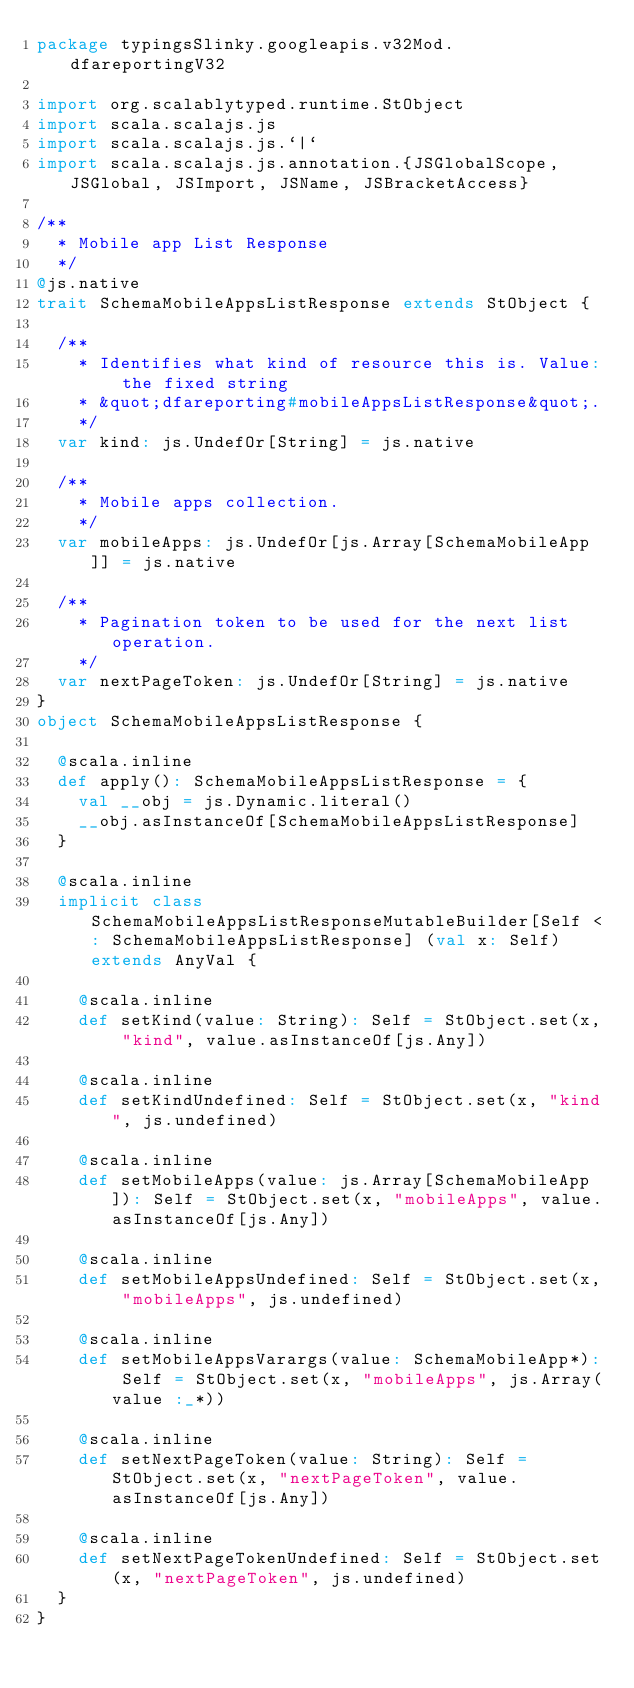Convert code to text. <code><loc_0><loc_0><loc_500><loc_500><_Scala_>package typingsSlinky.googleapis.v32Mod.dfareportingV32

import org.scalablytyped.runtime.StObject
import scala.scalajs.js
import scala.scalajs.js.`|`
import scala.scalajs.js.annotation.{JSGlobalScope, JSGlobal, JSImport, JSName, JSBracketAccess}

/**
  * Mobile app List Response
  */
@js.native
trait SchemaMobileAppsListResponse extends StObject {
  
  /**
    * Identifies what kind of resource this is. Value: the fixed string
    * &quot;dfareporting#mobileAppsListResponse&quot;.
    */
  var kind: js.UndefOr[String] = js.native
  
  /**
    * Mobile apps collection.
    */
  var mobileApps: js.UndefOr[js.Array[SchemaMobileApp]] = js.native
  
  /**
    * Pagination token to be used for the next list operation.
    */
  var nextPageToken: js.UndefOr[String] = js.native
}
object SchemaMobileAppsListResponse {
  
  @scala.inline
  def apply(): SchemaMobileAppsListResponse = {
    val __obj = js.Dynamic.literal()
    __obj.asInstanceOf[SchemaMobileAppsListResponse]
  }
  
  @scala.inline
  implicit class SchemaMobileAppsListResponseMutableBuilder[Self <: SchemaMobileAppsListResponse] (val x: Self) extends AnyVal {
    
    @scala.inline
    def setKind(value: String): Self = StObject.set(x, "kind", value.asInstanceOf[js.Any])
    
    @scala.inline
    def setKindUndefined: Self = StObject.set(x, "kind", js.undefined)
    
    @scala.inline
    def setMobileApps(value: js.Array[SchemaMobileApp]): Self = StObject.set(x, "mobileApps", value.asInstanceOf[js.Any])
    
    @scala.inline
    def setMobileAppsUndefined: Self = StObject.set(x, "mobileApps", js.undefined)
    
    @scala.inline
    def setMobileAppsVarargs(value: SchemaMobileApp*): Self = StObject.set(x, "mobileApps", js.Array(value :_*))
    
    @scala.inline
    def setNextPageToken(value: String): Self = StObject.set(x, "nextPageToken", value.asInstanceOf[js.Any])
    
    @scala.inline
    def setNextPageTokenUndefined: Self = StObject.set(x, "nextPageToken", js.undefined)
  }
}
</code> 